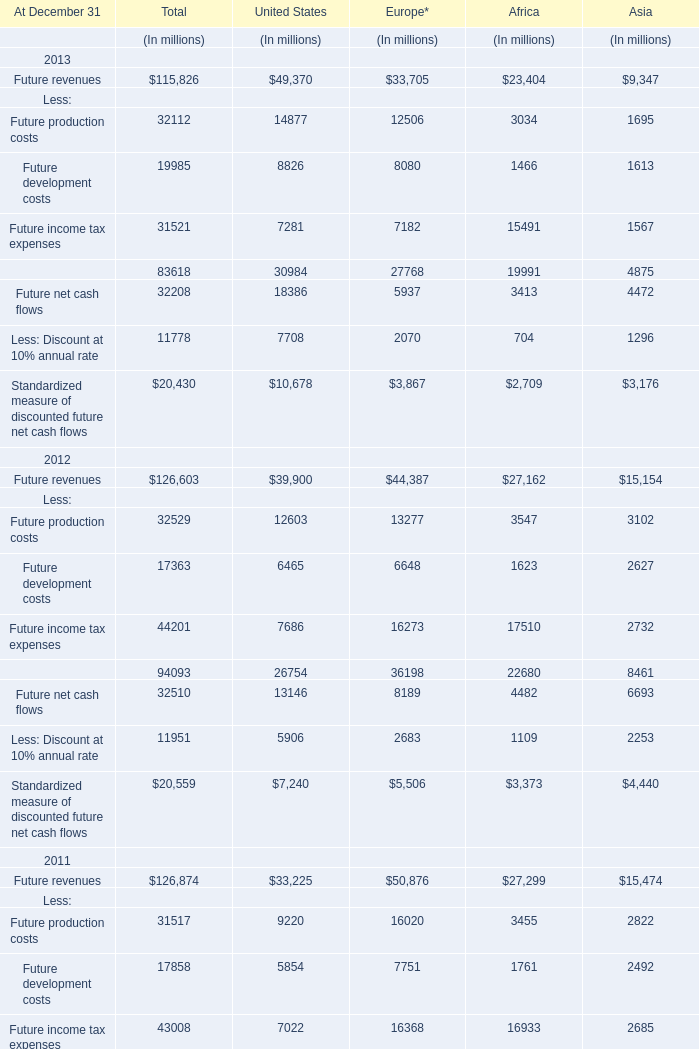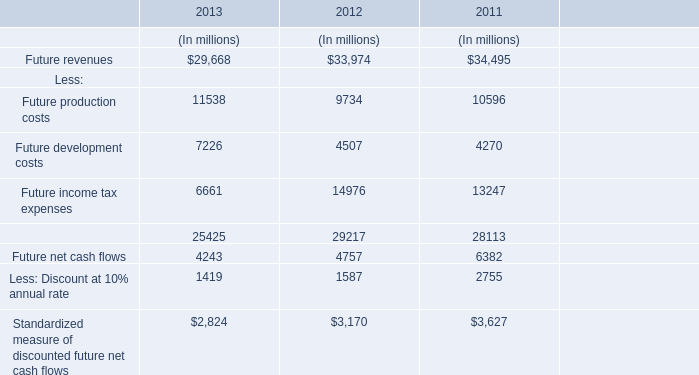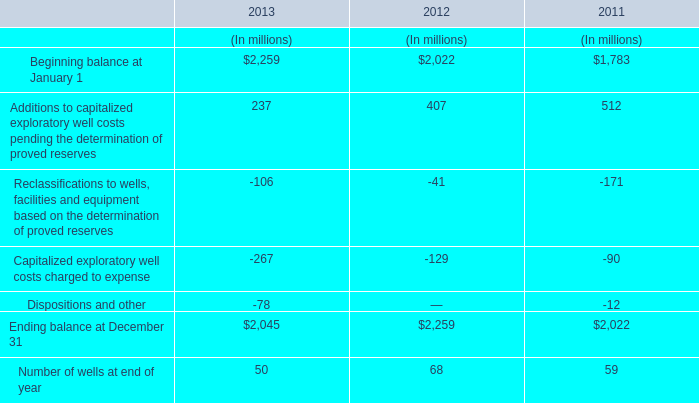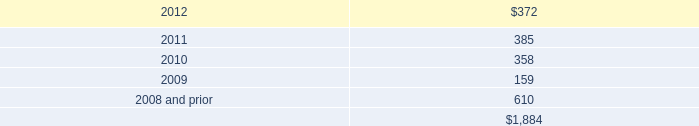what was the percentage change in total expense for repairs and maintenance from 2012 to 2013? 
Computations: ((2.3 - 2.1) / 2.1)
Answer: 0.09524. 